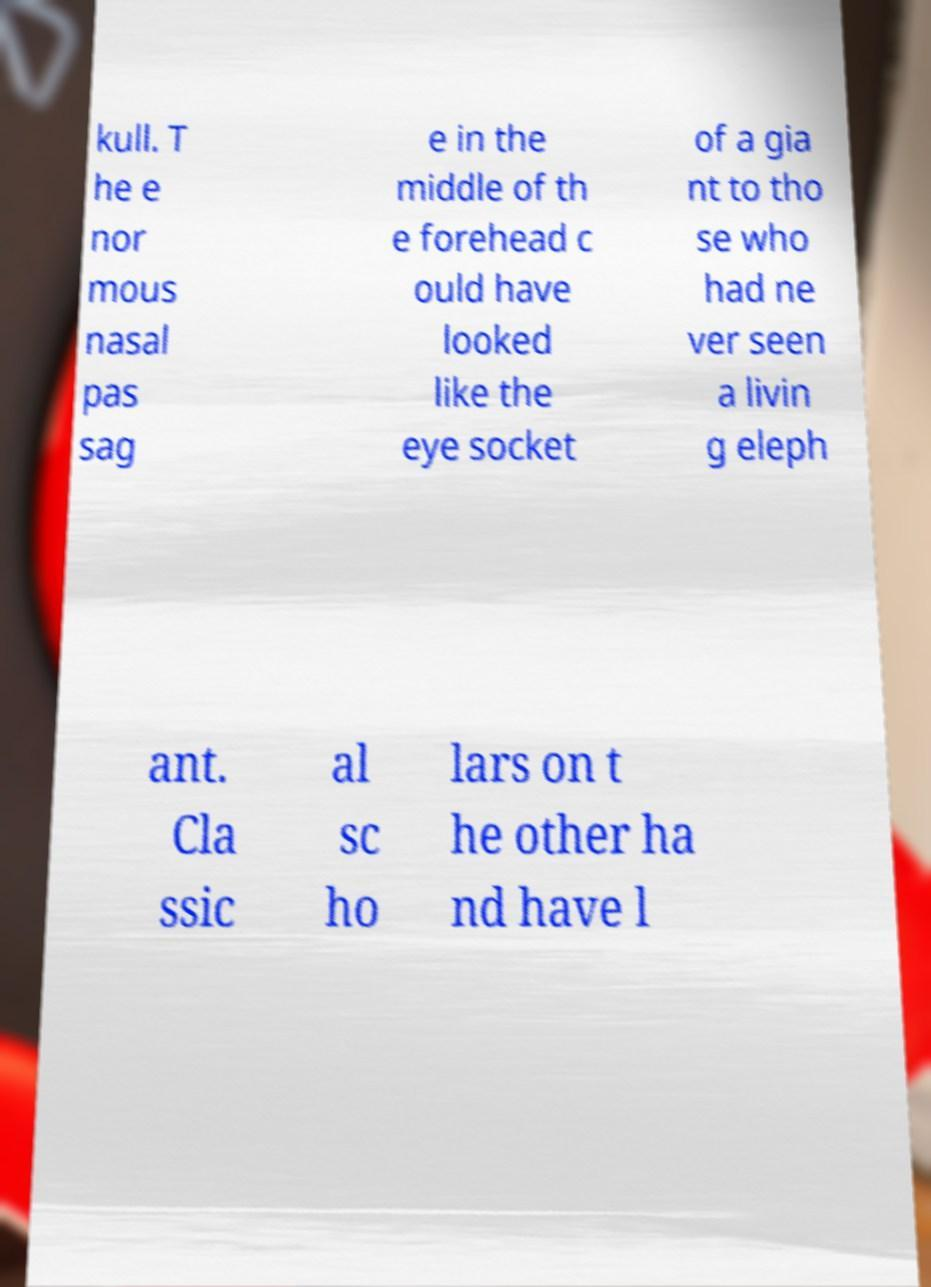I need the written content from this picture converted into text. Can you do that? kull. T he e nor mous nasal pas sag e in the middle of th e forehead c ould have looked like the eye socket of a gia nt to tho se who had ne ver seen a livin g eleph ant. Cla ssic al sc ho lars on t he other ha nd have l 